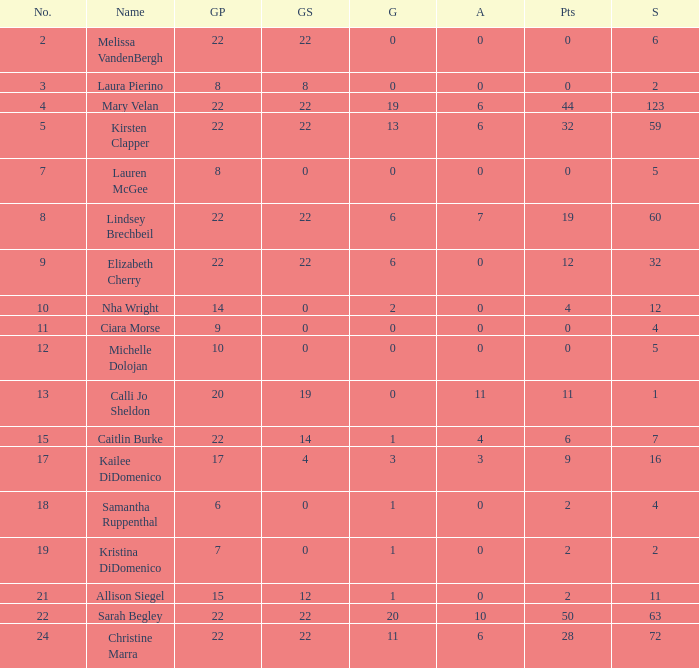How many games played catagories are there for Lauren McGee?  1.0. 